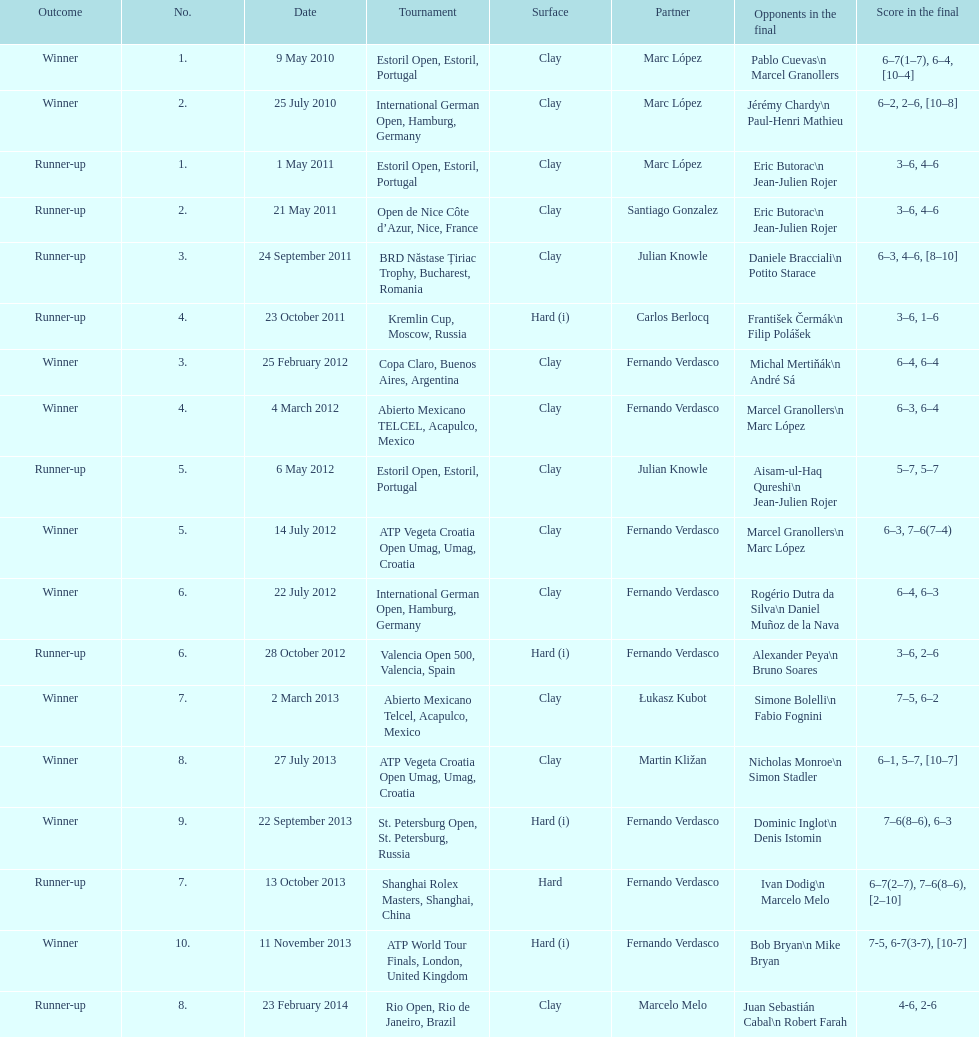What is the count of successful outcomes? 10. 